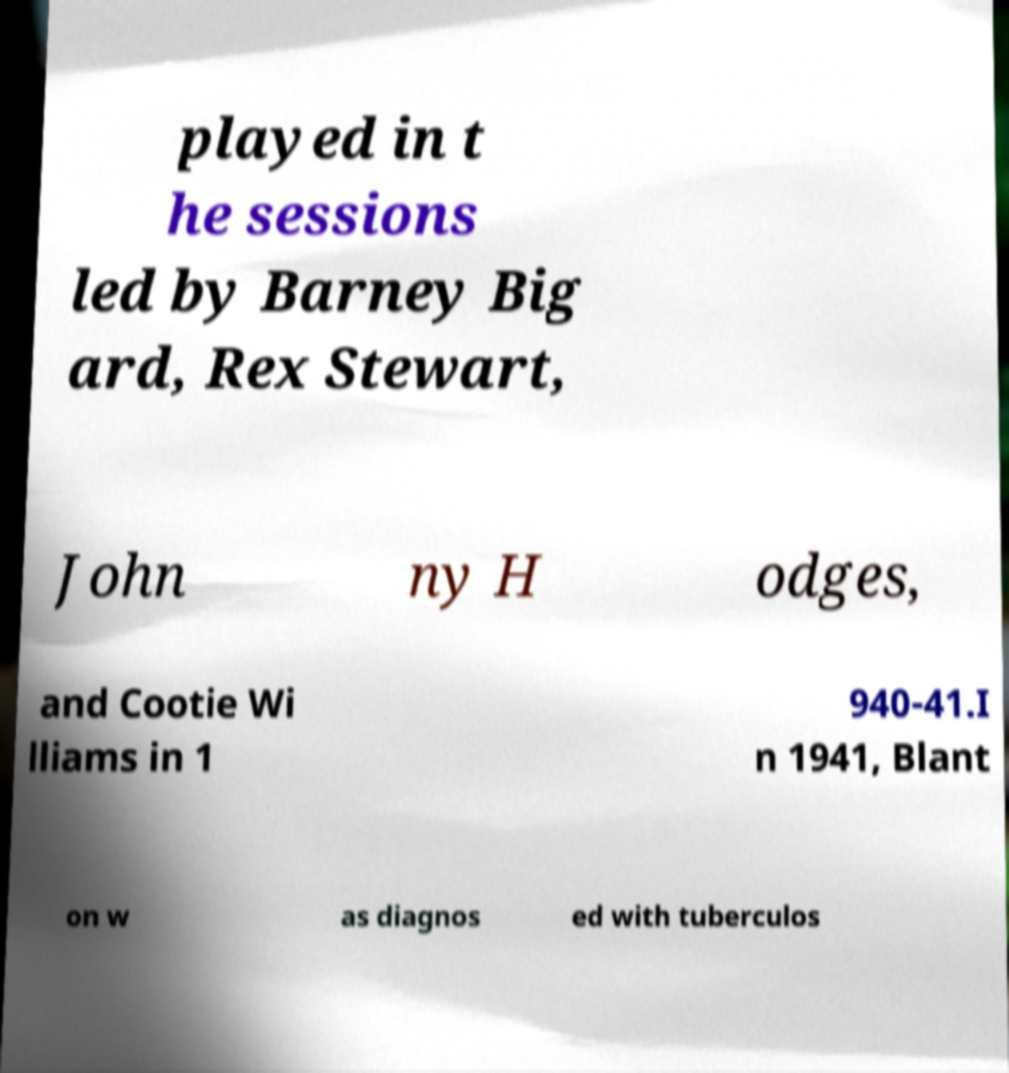Please identify and transcribe the text found in this image. played in t he sessions led by Barney Big ard, Rex Stewart, John ny H odges, and Cootie Wi lliams in 1 940-41.I n 1941, Blant on w as diagnos ed with tuberculos 